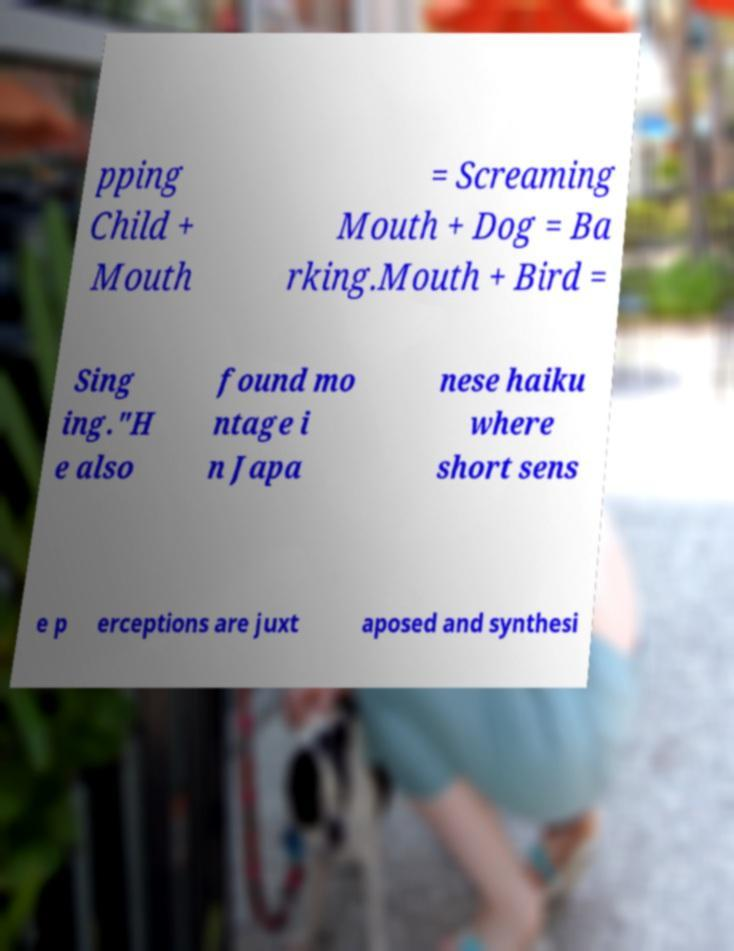What messages or text are displayed in this image? I need them in a readable, typed format. pping Child + Mouth = Screaming Mouth + Dog = Ba rking.Mouth + Bird = Sing ing."H e also found mo ntage i n Japa nese haiku where short sens e p erceptions are juxt aposed and synthesi 